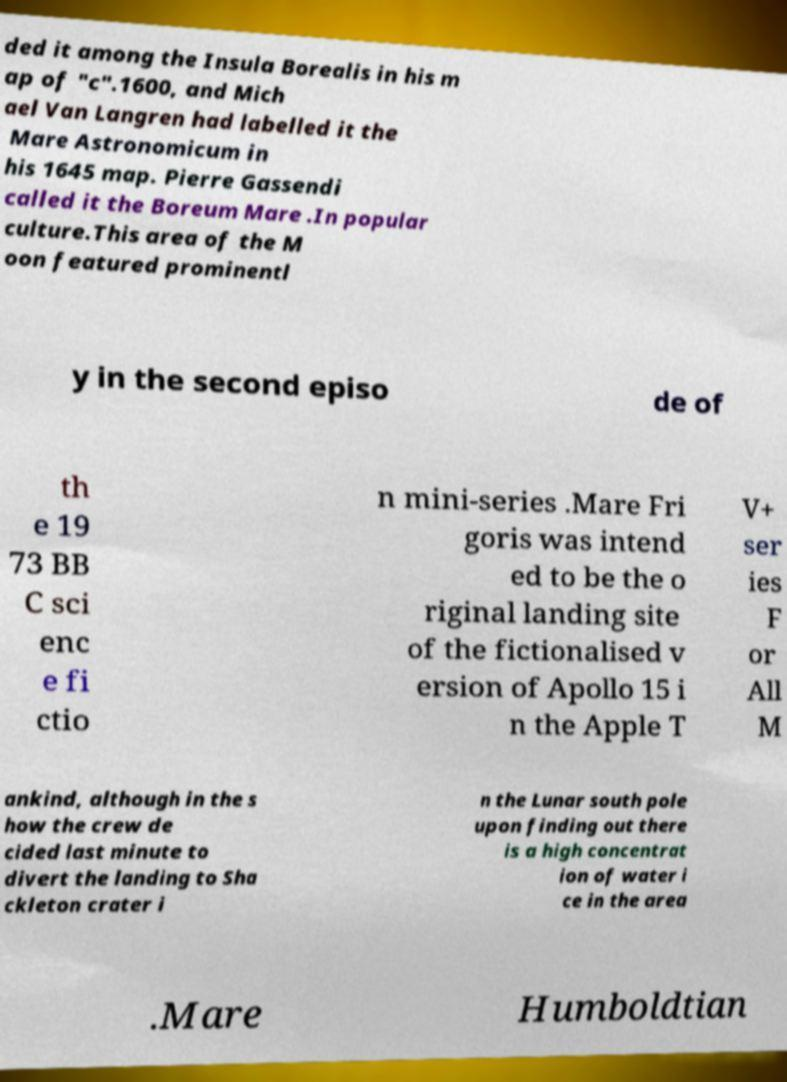Please identify and transcribe the text found in this image. ded it among the Insula Borealis in his m ap of "c".1600, and Mich ael Van Langren had labelled it the Mare Astronomicum in his 1645 map. Pierre Gassendi called it the Boreum Mare .In popular culture.This area of the M oon featured prominentl y in the second episo de of th e 19 73 BB C sci enc e fi ctio n mini-series .Mare Fri goris was intend ed to be the o riginal landing site of the fictionalised v ersion of Apollo 15 i n the Apple T V+ ser ies F or All M ankind, although in the s how the crew de cided last minute to divert the landing to Sha ckleton crater i n the Lunar south pole upon finding out there is a high concentrat ion of water i ce in the area .Mare Humboldtian 